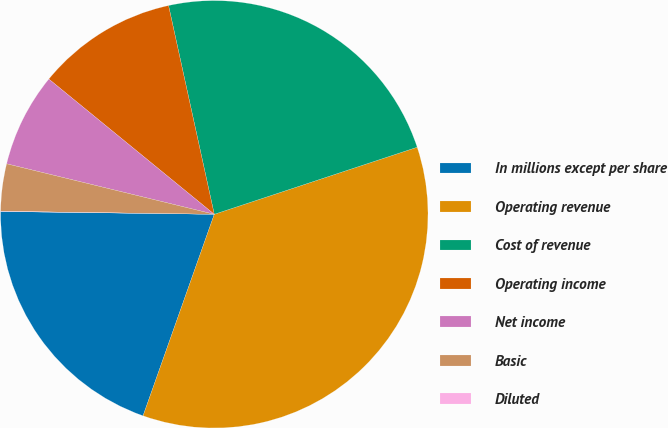Convert chart. <chart><loc_0><loc_0><loc_500><loc_500><pie_chart><fcel>In millions except per share<fcel>Operating revenue<fcel>Cost of revenue<fcel>Operating income<fcel>Net income<fcel>Basic<fcel>Diluted<nl><fcel>19.8%<fcel>35.49%<fcel>23.35%<fcel>10.66%<fcel>7.11%<fcel>3.57%<fcel>0.02%<nl></chart> 